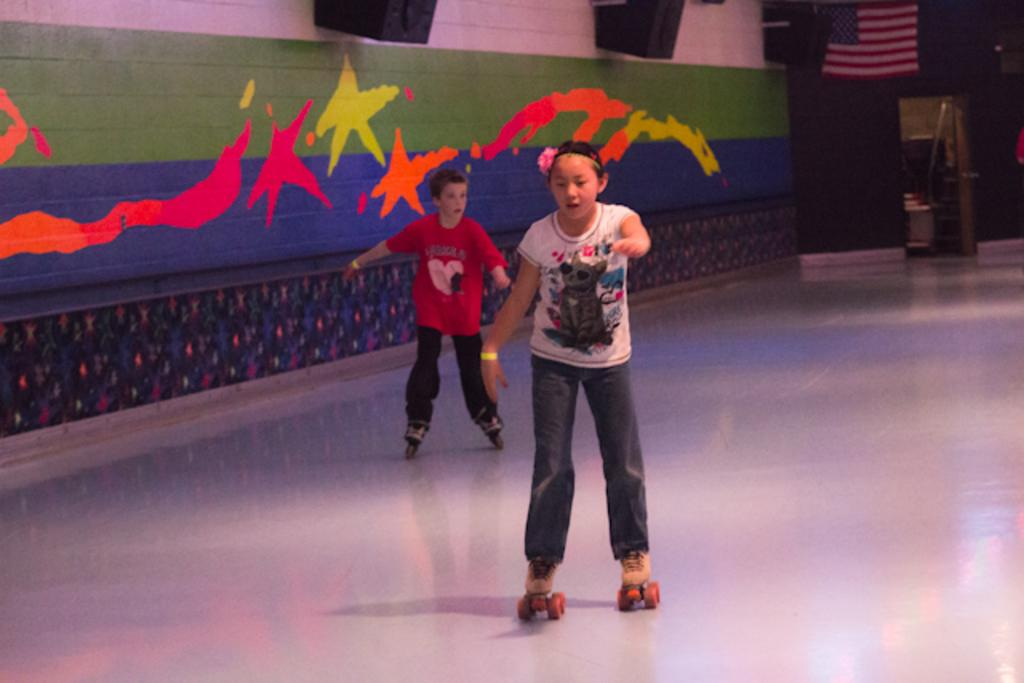How many kids are in the image? There are two kids in the image. What are the kids doing in the image? The kids are on skateboards. What is the surface they are skateboarding on? There is a floor in the image. What can be seen on the wall in the image? There is a painted wall in the image. What symbol is present in the image? There is a USA flag in the image. Can you tell me the opinion of the tiger in the image? There is no tiger present in the image, so it is not possible to determine its opinion. Is there a lake visible in the image? No, there is no lake visible in the image. 